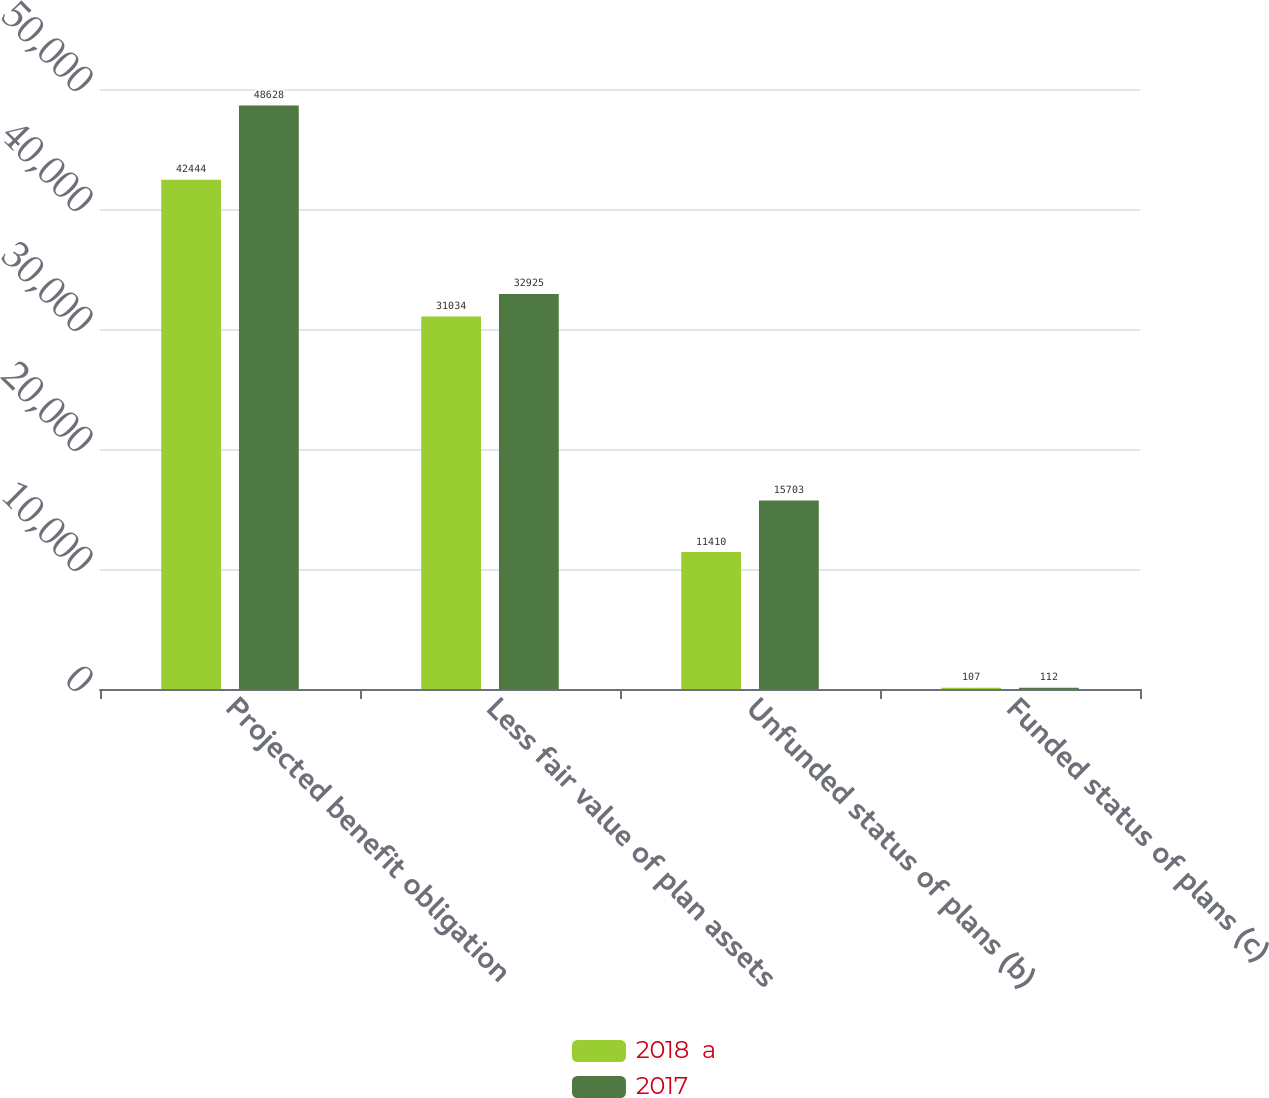<chart> <loc_0><loc_0><loc_500><loc_500><stacked_bar_chart><ecel><fcel>Projected benefit obligation<fcel>Less fair value of plan assets<fcel>Unfunded status of plans (b)<fcel>Funded status of plans (c)<nl><fcel>2018  a<fcel>42444<fcel>31034<fcel>11410<fcel>107<nl><fcel>2017<fcel>48628<fcel>32925<fcel>15703<fcel>112<nl></chart> 